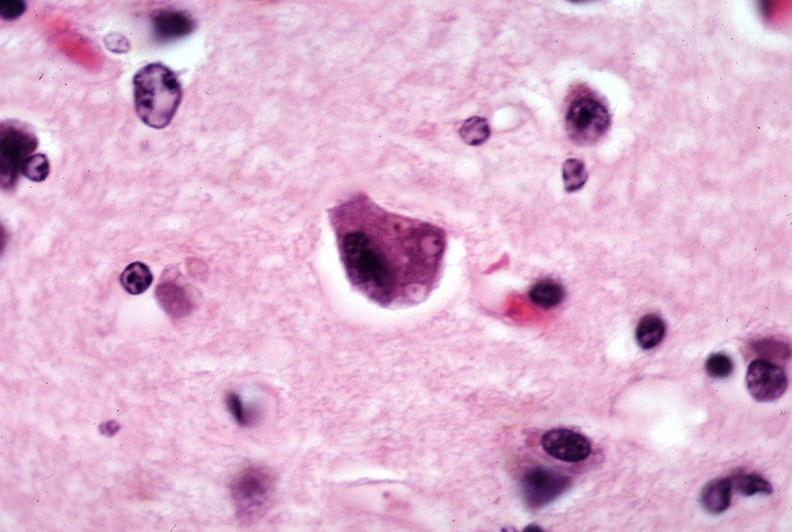what does this image show?
Answer the question using a single word or phrase. Brain 